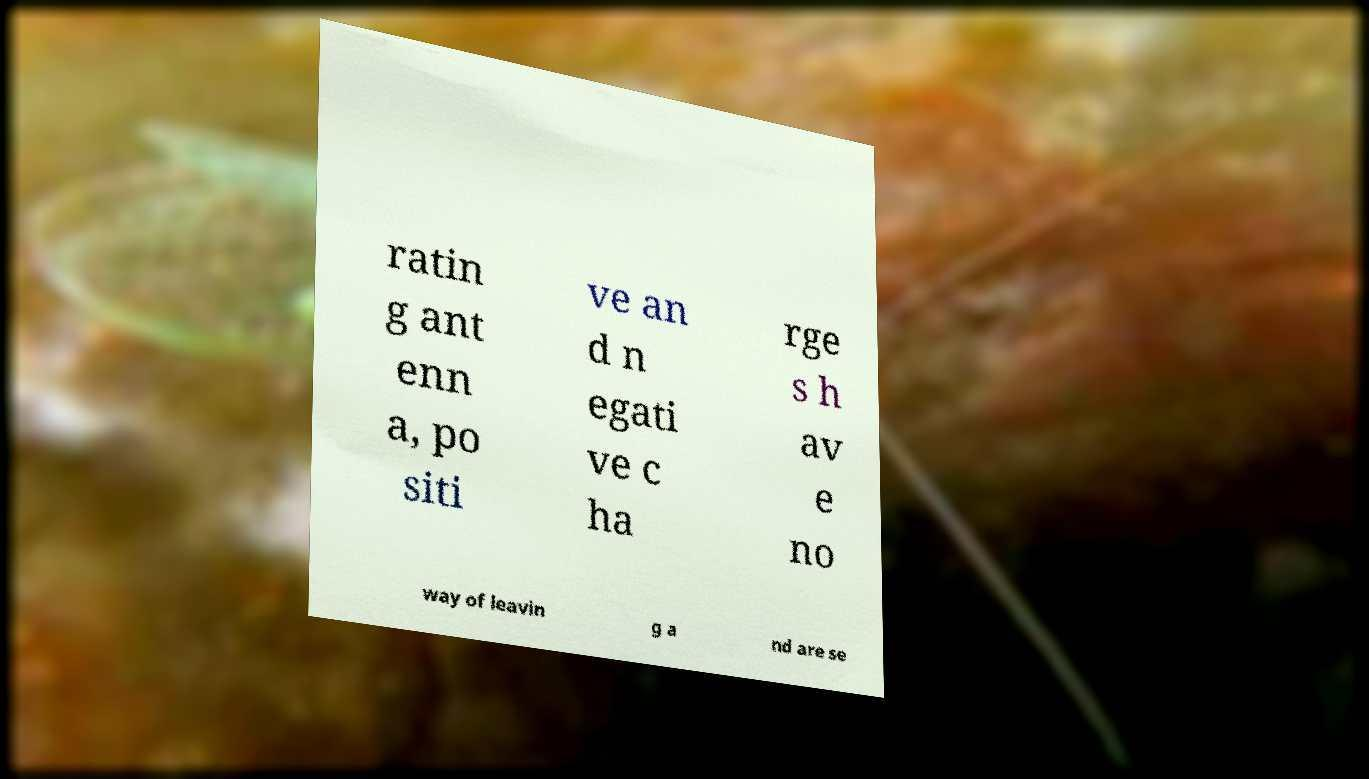There's text embedded in this image that I need extracted. Can you transcribe it verbatim? ratin g ant enn a, po siti ve an d n egati ve c ha rge s h av e no way of leavin g a nd are se 